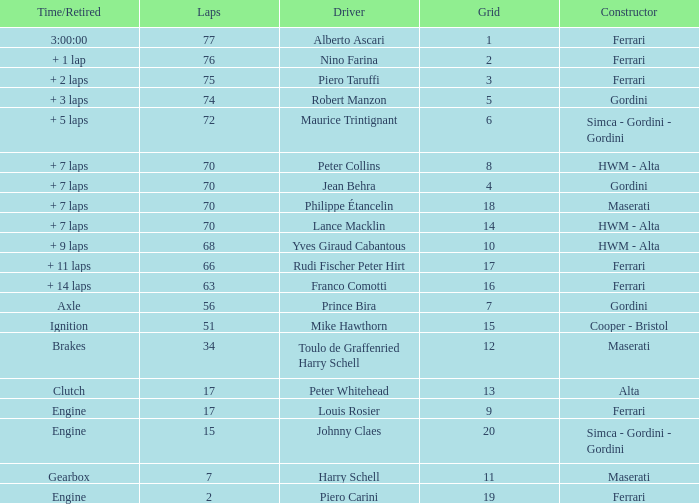How many grids for peter collins? 1.0. 